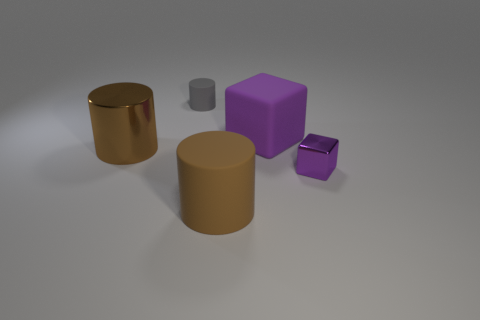Subtract all tiny rubber cylinders. How many cylinders are left? 2 Subtract all purple balls. How many brown cylinders are left? 2 Add 1 cyan matte blocks. How many objects exist? 6 Subtract all gray cylinders. How many cylinders are left? 2 Subtract all cylinders. How many objects are left? 2 Subtract all green cylinders. Subtract all purple spheres. How many cylinders are left? 3 Add 4 brown rubber cylinders. How many brown rubber cylinders are left? 5 Add 2 small purple metallic things. How many small purple metallic things exist? 3 Subtract 1 brown cylinders. How many objects are left? 4 Subtract all small gray things. Subtract all tiny matte things. How many objects are left? 3 